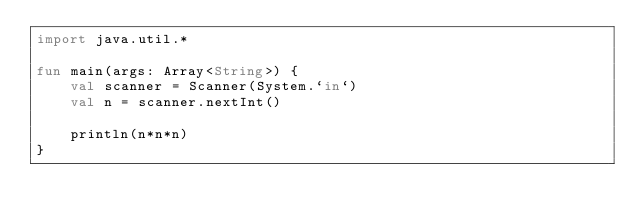Convert code to text. <code><loc_0><loc_0><loc_500><loc_500><_Kotlin_>import java.util.*

fun main(args: Array<String>) {
    val scanner = Scanner(System.`in`)
    val n = scanner.nextInt()

    println(n*n*n)
}</code> 